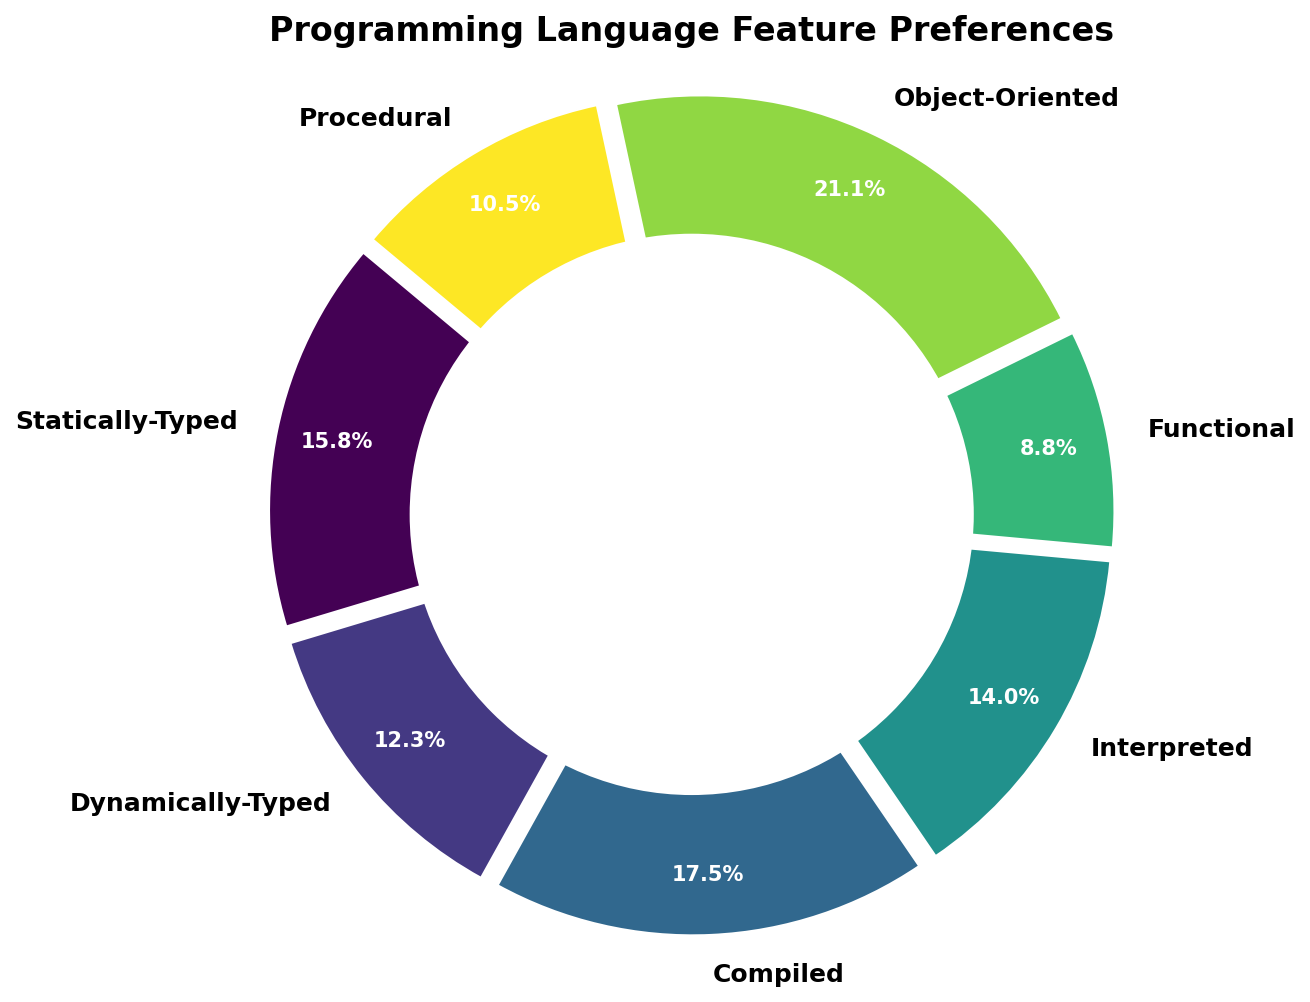Which feature has the highest percentage preference? First, look at all the slices in the pie chart and identify the one with the largest size. The label "Object-Oriented" corresponds to the largest slice, indicating it has the highest percentage preference.
Answer: Object-Oriented How much more popular are compiled languages compared to interpreted languages? Find the percentages for both "Compiled" and "Interpreted" from their respective slices in the pie chart. Subtract the percentage of interpreted languages (40%) from that of compiled languages (50%) to determine the difference.
Answer: 10% Which feature type is least preferred by developers? Identify the smallest slice in the pie chart. The label "Functional" corresponds to this slice, indicating it has the lowest percentage preference.
Answer: Functional What is the combined percentage of developers who prefer Statically-Typed and Dynamically-Typed languages? Locate the percentages for "Statically-Typed" (45%) and "Dynamically-Typed" (35%) in the pie chart. Add these together to get the combined percentage.
Answer: 80% Is the percentage of developers who prefer Procedural languages higher or lower than those who prefer Functional languages? Compare the sizes of the slices labeled "Procedural" and "Functional." "Procedural" has a higher percentage (30%) compared to "Functional" (25%).
Answer: Higher How much greater is the preference for Object-Oriented languages compared to Functional languages? Locate the percentages for both "Object-Oriented" (60%) and "Functional" (25%) in the pie chart. Subtract the percentage of "Functional" from that of "Object-Oriented" to find the difference.
Answer: 35% What percentage of developers prefer Compiled or Interpreted languages combined? Find and sum the percentages for both "Compiled" (50%) and "Interpreted" (40%) in the pie chart.
Answer: 90% Are the percentages of developers who prefer Statically-Typed and Compiled languages equal? Compare the sizes of the slices for "Statically-Typed" and "Compiled." Both slices correspond to different percentages, 45% and 50% respectively, indicating they are not equal.
Answer: No Which feature type has a percentage closest to 30%? Find the slice that represents Procedural languages. Its label indicates that it has a percentage of 30%, which matches the query.
Answer: Procedural 